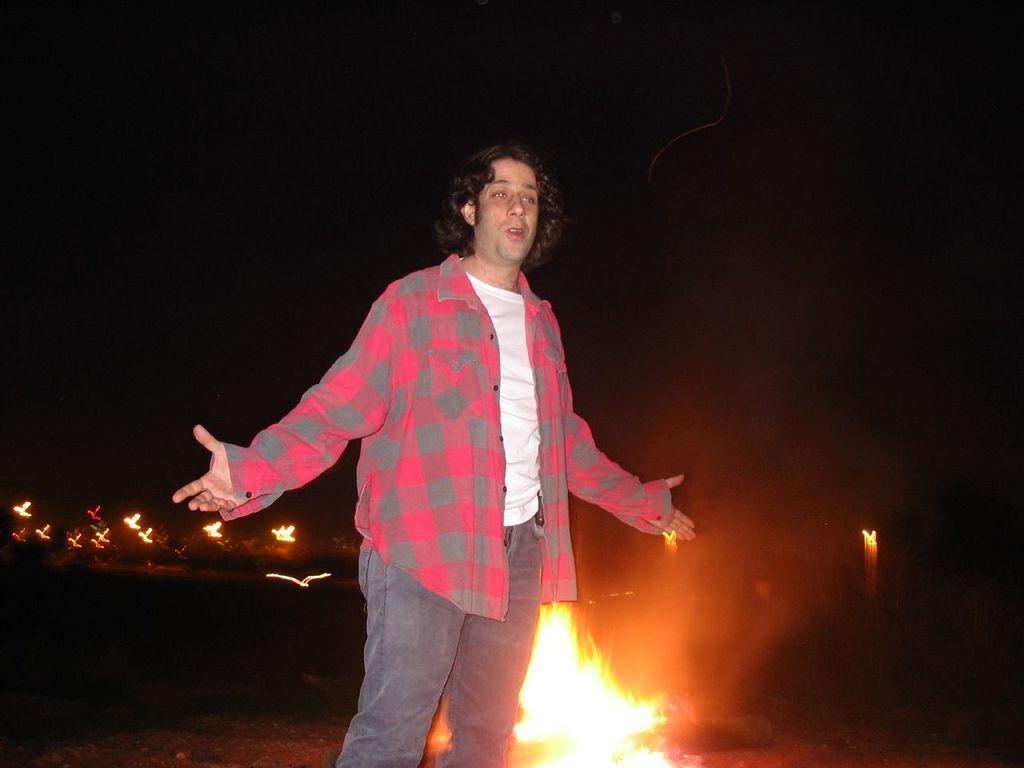In one or two sentences, can you explain what this image depicts? A man is standing, this is fire, there is black color background. 